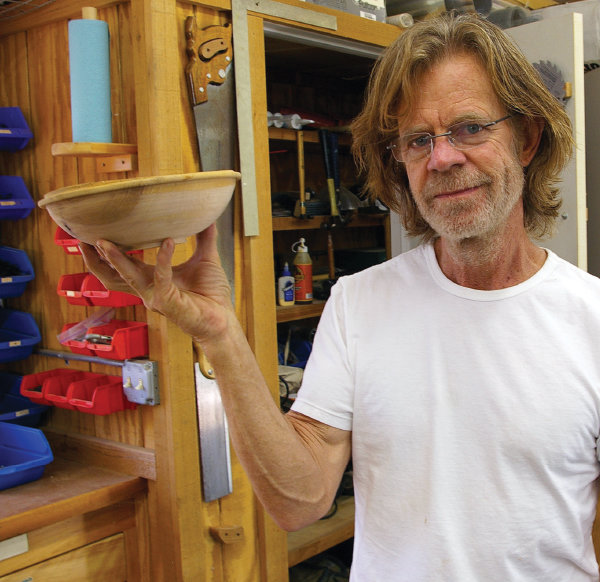Explain the visual content of the image in great detail. In the image, we see an individual standing in a workshop environment, presenting a handcrafted wooden bowl. The person is facing the camera with a content expression, and they are wearing a simple white t-shirt and glasses. The workshop contains various tools and woodworking paraphernalia neatly stored on the shelves and wall racks which include clamps, saws, and what appears to be bottles of wood treatments or stains. Natural light fills the room, highlighting the wood's warm tones and the individual's detailed craftsmanship. 